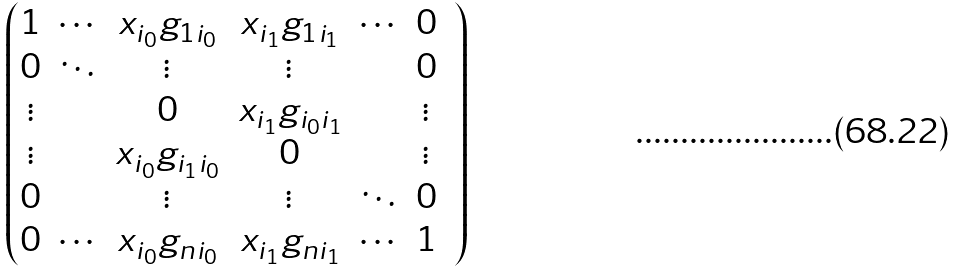<formula> <loc_0><loc_0><loc_500><loc_500>\begin{pmatrix} 1 & \cdots & x _ { i _ { 0 } } g _ { 1 i _ { 0 } } & x _ { i _ { 1 } } g _ { 1 i _ { 1 } } & \cdots & 0 & \\ 0 & \ddots & \vdots & \vdots & & 0 & \\ \vdots & & 0 & x _ { i _ { 1 } } g _ { i _ { 0 } i _ { 1 } } & & \vdots & \\ \vdots & & x _ { i _ { 0 } } g _ { i _ { 1 } i _ { 0 } } & 0 & & \vdots & \\ 0 & & \vdots & \vdots & \ddots & 0 & \\ 0 & \cdots & x _ { i _ { 0 } } g _ { n i _ { 0 } } & x _ { i _ { 1 } } g _ { n i _ { 1 } } & \cdots & 1 & \end{pmatrix}</formula> 